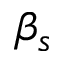Convert formula to latex. <formula><loc_0><loc_0><loc_500><loc_500>\beta _ { s }</formula> 